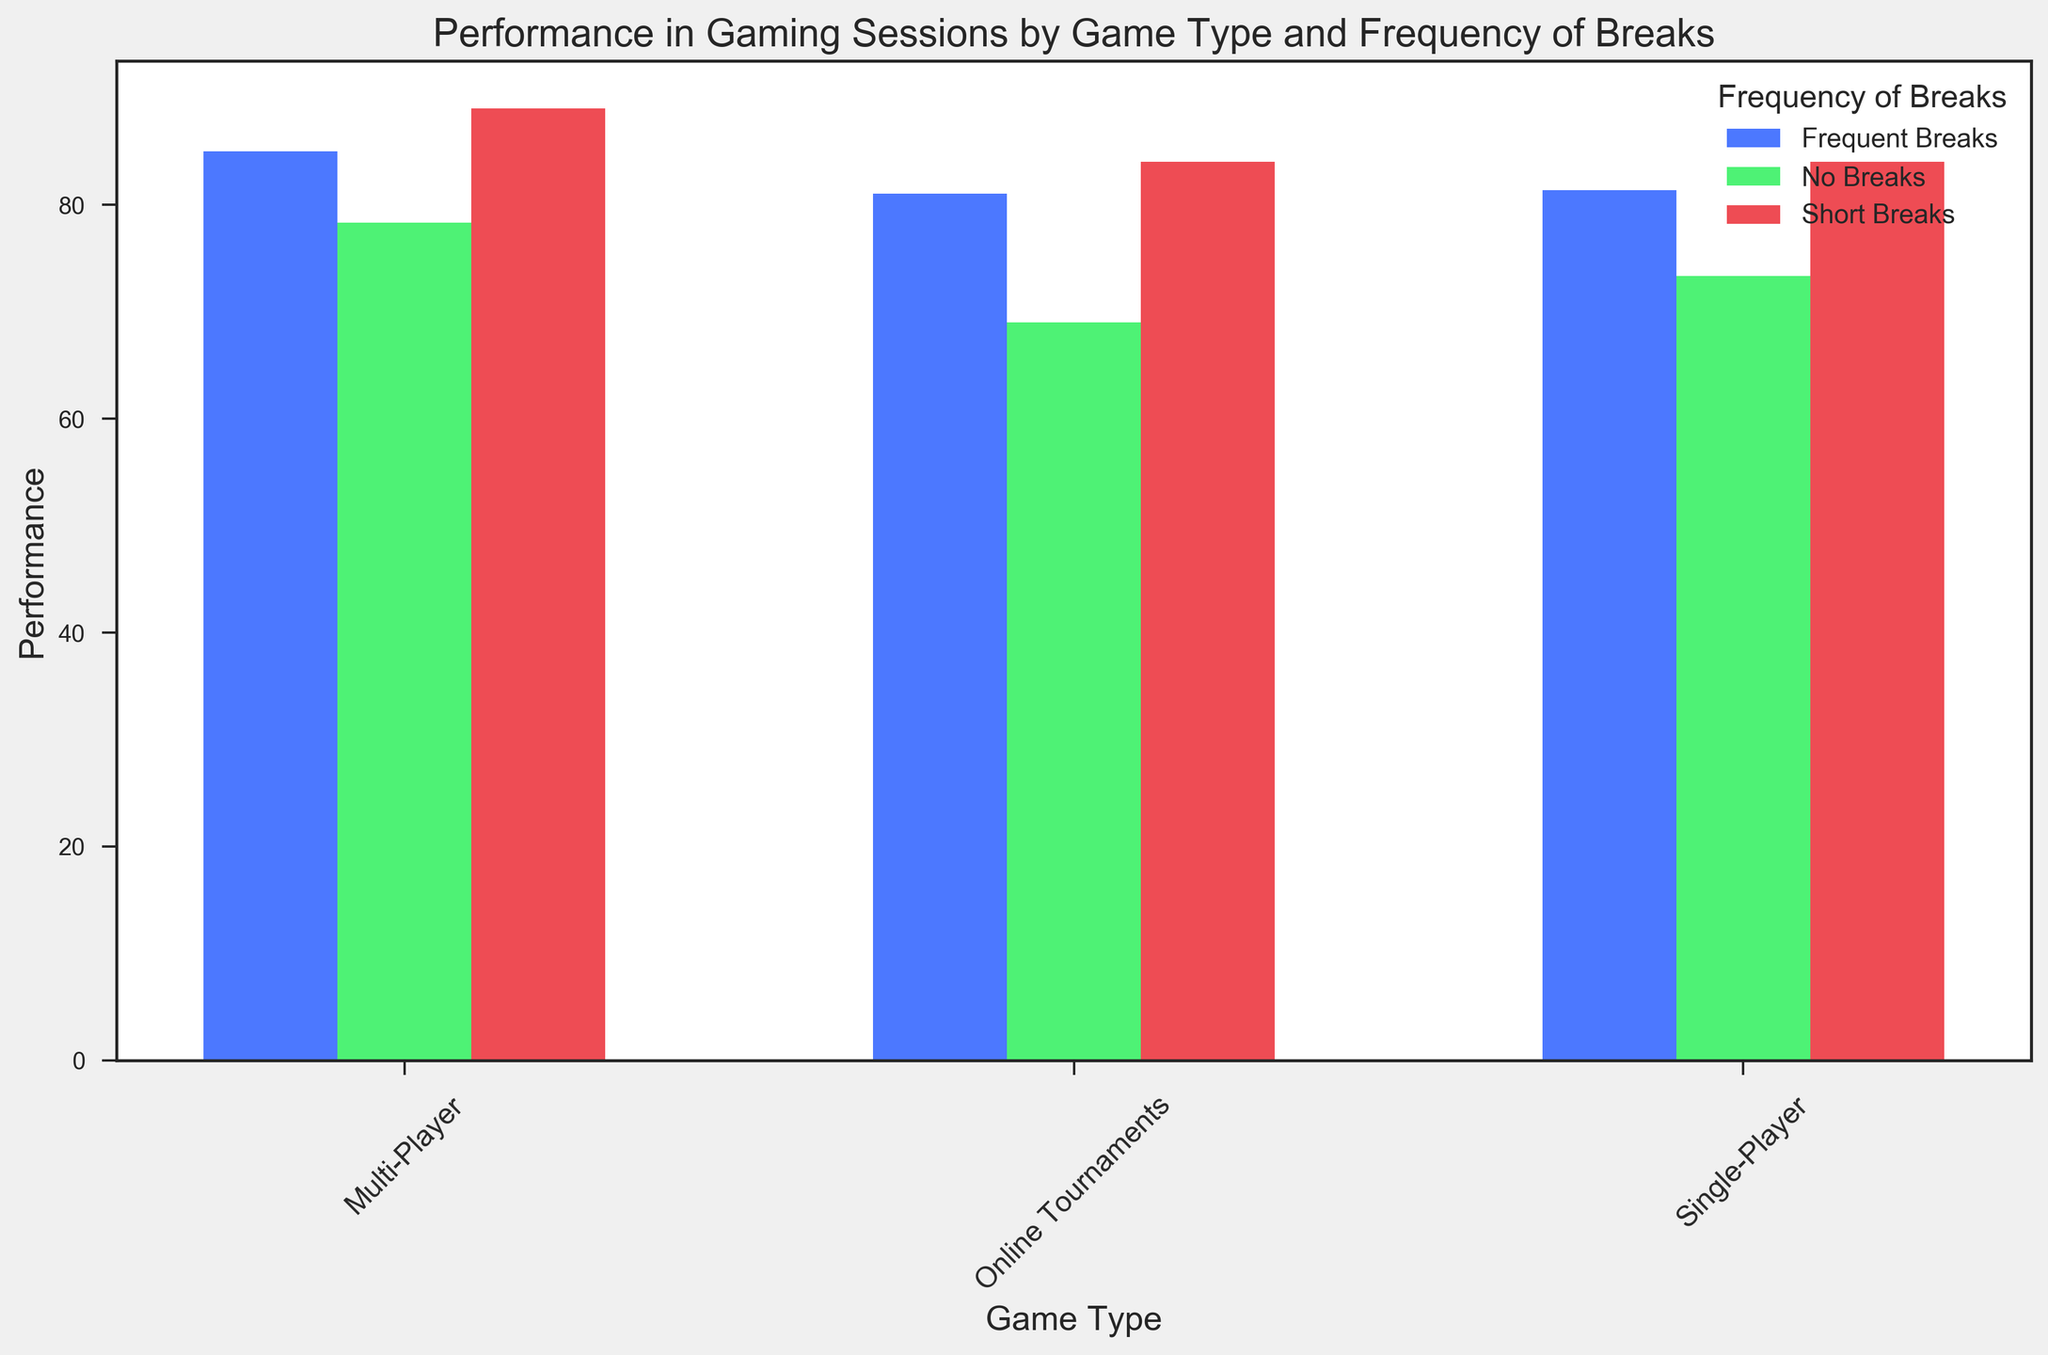What game type shows the highest average performance when taking frequent breaks? By analyzing the heights of the bars associated with "Frequent Breaks" across all game types, we can observe which bar is tallest. The "Multi-Player" game type shows the highest bar in the "Frequent Breaks" category.
Answer: Multi-Player Which frequency of breaks results in the lowest performance in online tournaments? By comparing the bars for each frequency of breaks within the "Online Tournaments" category, we can identify the shortest bar. The "No Breaks" category has the lowest bar.
Answer: No Breaks How much higher is the average performance for short breaks compared to no breaks in single-player games? To find this, calculate the difference between the heights of the bars representing "Short Breaks" and "No Breaks" in the "Single-Player" game type. The heights are approximately 84 and 73, respectively, so the difference is 84 - 73.
Answer: 11 What is the rounded average performance for all categories in multi-player games? Calculate the mean performance for "No Breaks," "Short Breaks," and "Frequent Breaks" categories in multi-player games. The calculations are (78 + 88 + 86) / 3.
Answer: 84 Which game type appears to benefit the most from short breaks? Compare the performance bars for "Short Breaks" across all game types. The highest bar in the "Short Breaks" category belongs to the "Multi-Player" game type.
Answer: Multi-Player Is performance generally higher with short breaks or frequent breaks across all game types? To determine this, compare the average height of the bars for "Short Breaks" and "Frequent Breaks" across all game types. In general, the "Short Breaks" bars appear taller.
Answer: Short Breaks What is the overall average performance for single-player games across all break frequencies? Compute the mean performance for "No Breaks," "Short Breaks," and "Frequent Breaks" in single-player games by summing their values and dividing by 3. The calculations are (73 + 84 + 81) / 3.
Answer: 79.3 Which group shows the smallest improvement from no breaks to short breaks? Check the difference in performance between "No Breaks" and "Short Breaks" bars for each game type. The smallest difference appears in the "Online Tournaments" category.
Answer: Online Tournaments How does the average performance in online tournaments with frequent breaks compare to multi-player games with no breaks? Identify the frequencies for "Online Tournaments" with "Frequent Breaks" and "Multi-Player" with "No Breaks." The values are approximately 81 and 78, respectively. Calculate the difference 81 - 78.
Answer: 3 higher in Online Tournaments 